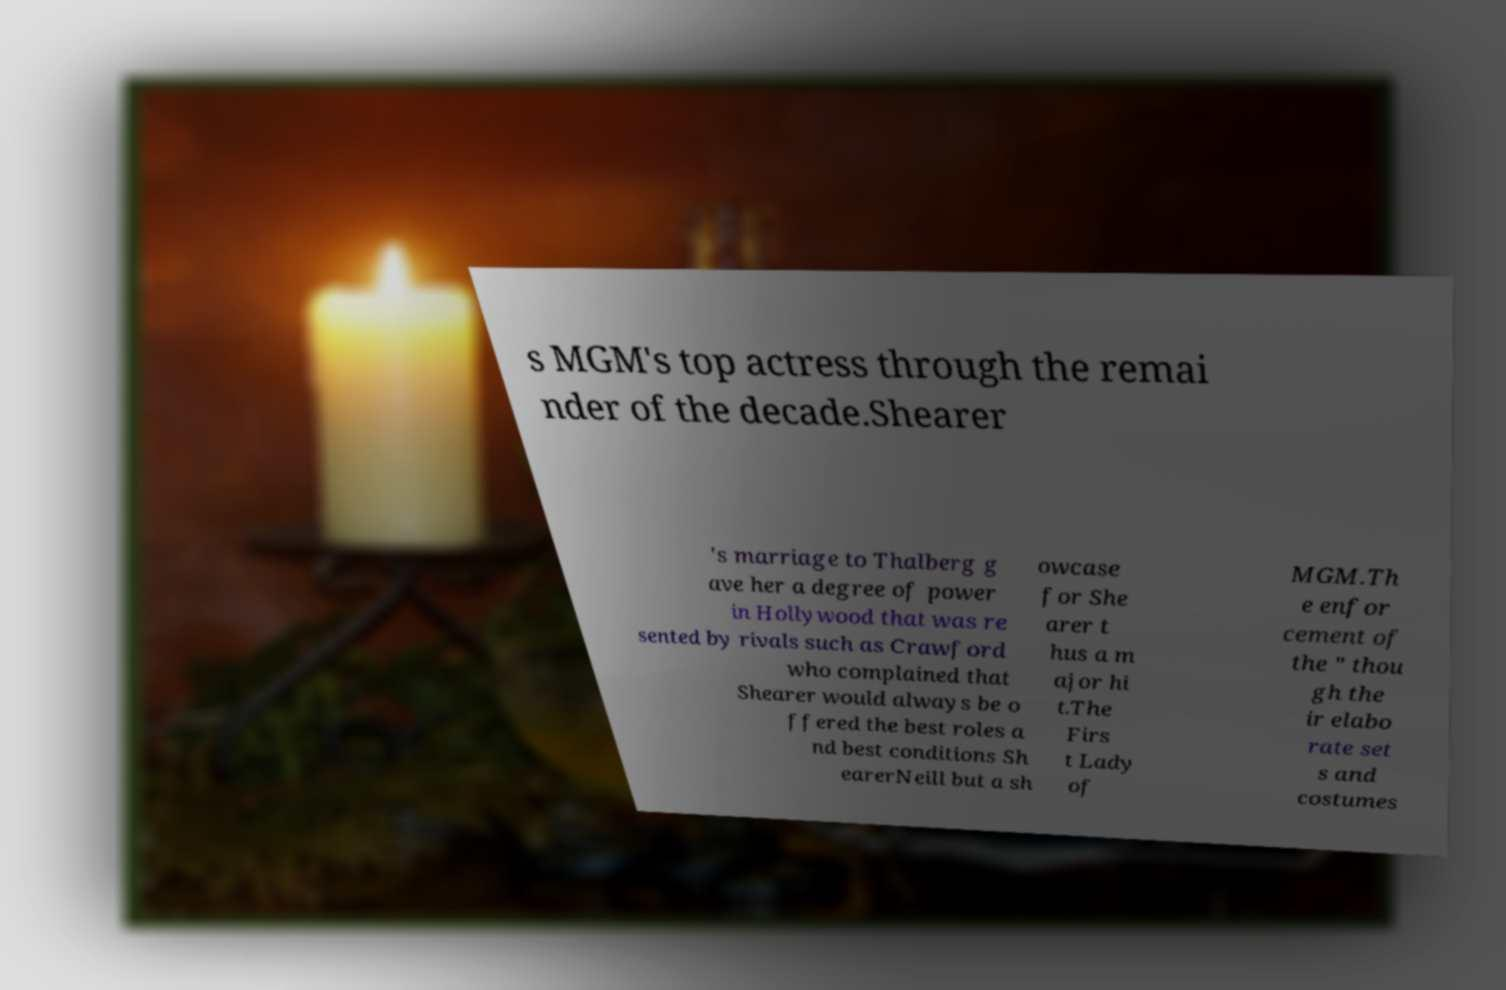Please identify and transcribe the text found in this image. s MGM's top actress through the remai nder of the decade.Shearer 's marriage to Thalberg g ave her a degree of power in Hollywood that was re sented by rivals such as Crawford who complained that Shearer would always be o ffered the best roles a nd best conditions Sh earerNeill but a sh owcase for She arer t hus a m ajor hi t.The Firs t Lady of MGM.Th e enfor cement of the " thou gh the ir elabo rate set s and costumes 